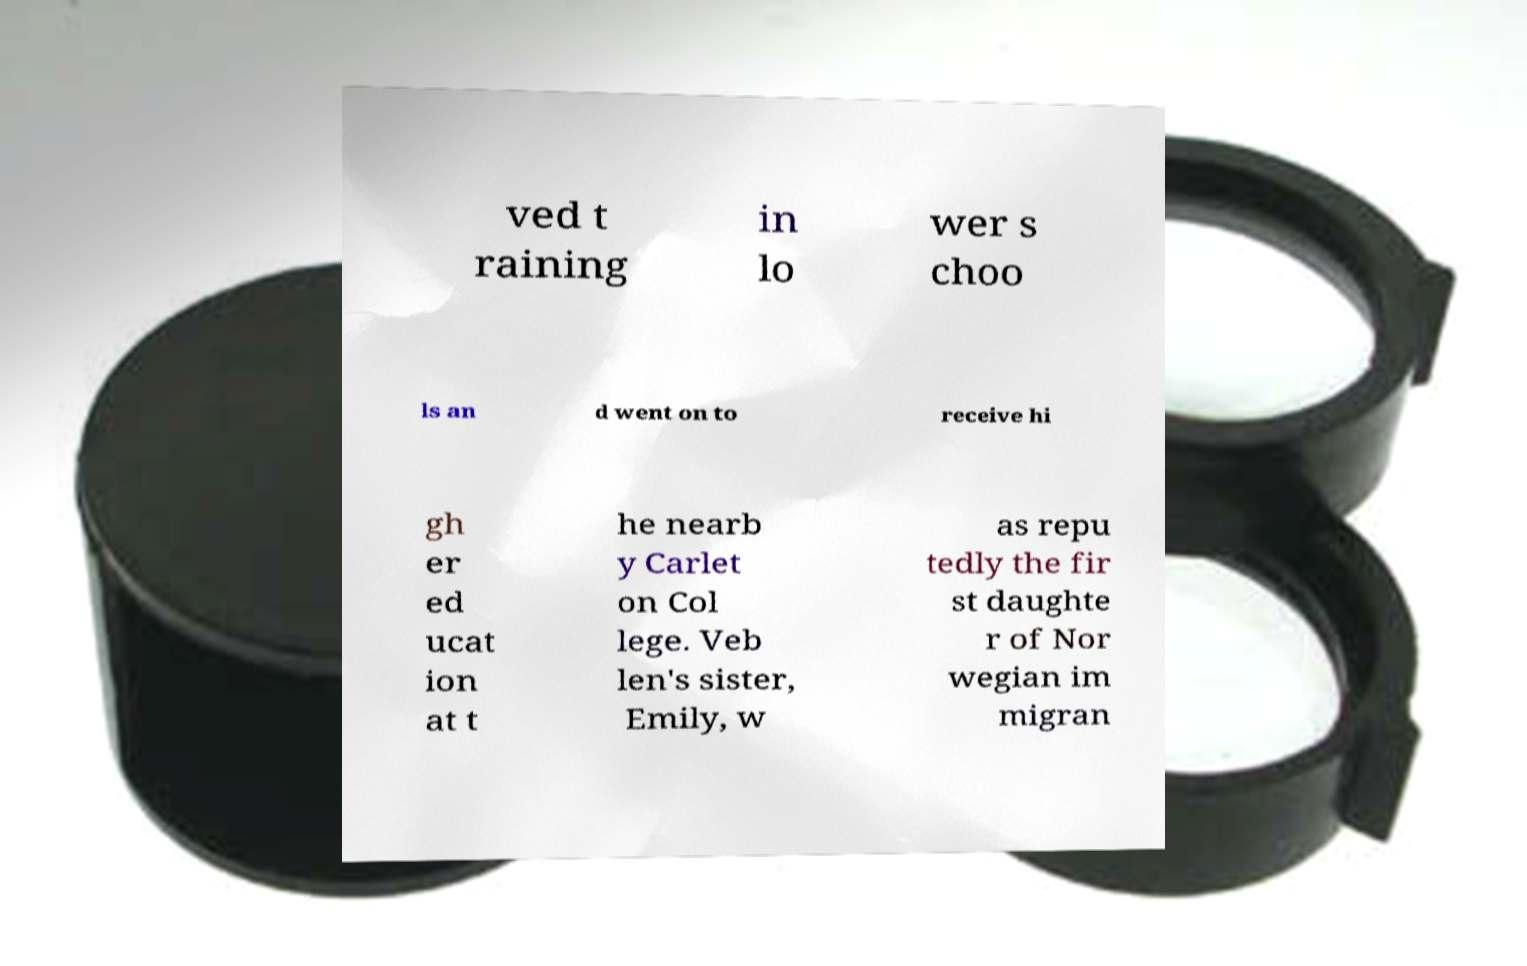I need the written content from this picture converted into text. Can you do that? ved t raining in lo wer s choo ls an d went on to receive hi gh er ed ucat ion at t he nearb y Carlet on Col lege. Veb len's sister, Emily, w as repu tedly the fir st daughte r of Nor wegian im migran 